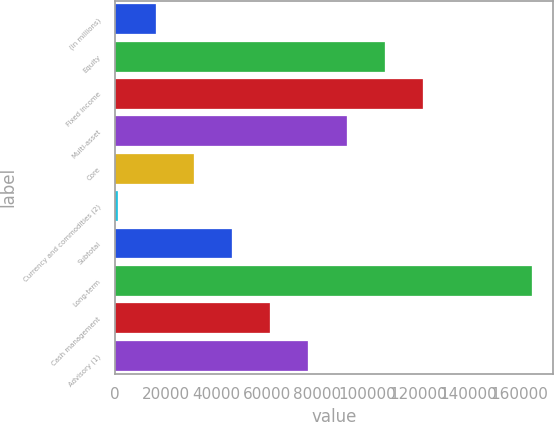Convert chart to OTSL. <chart><loc_0><loc_0><loc_500><loc_500><bar_chart><fcel>(in millions)<fcel>Equity<fcel>Fixed income<fcel>Multi-asset<fcel>Core<fcel>Currency and commodities (2)<fcel>Subtotal<fcel>Long-term<fcel>Cash management<fcel>Advisory (1)<nl><fcel>16141.9<fcel>106723<fcel>121820<fcel>91626.4<fcel>31238.8<fcel>1045<fcel>46335.7<fcel>164992<fcel>61432.6<fcel>76529.5<nl></chart> 